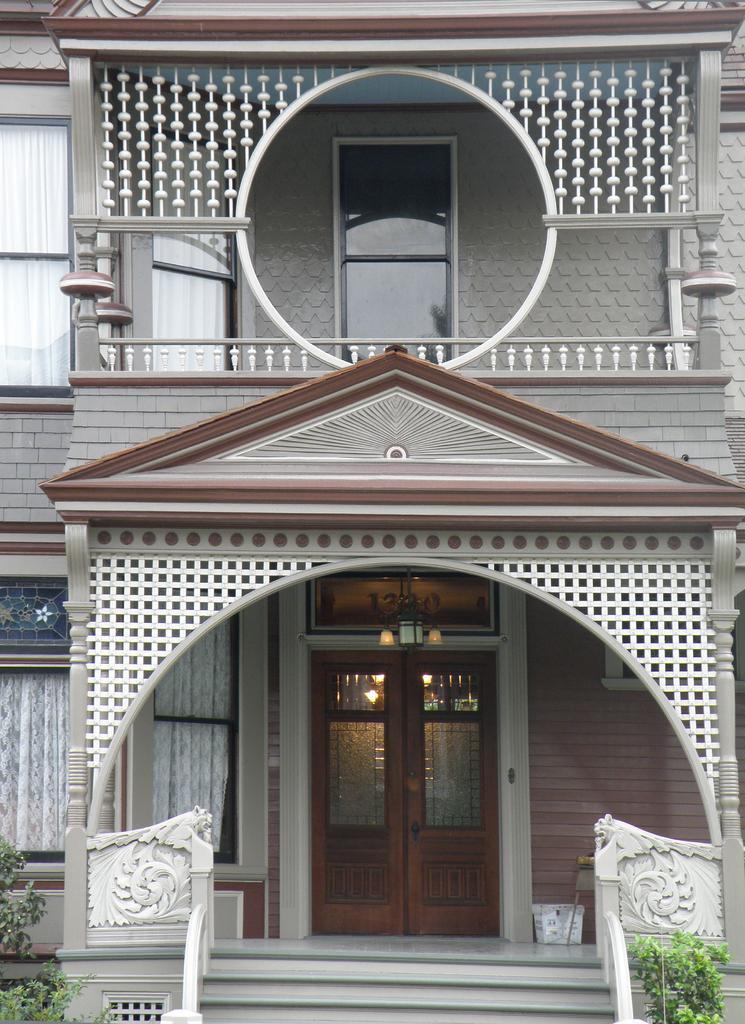In one or two sentences, can you explain what this image depicts? In the foreground of this image, there is a building, where we can see door, windows, stairs, plants and the curtains. 